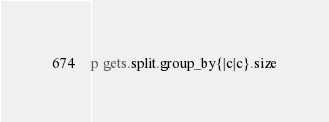<code> <loc_0><loc_0><loc_500><loc_500><_Ruby_>p gets.split.group_by{|c|c}.size</code> 